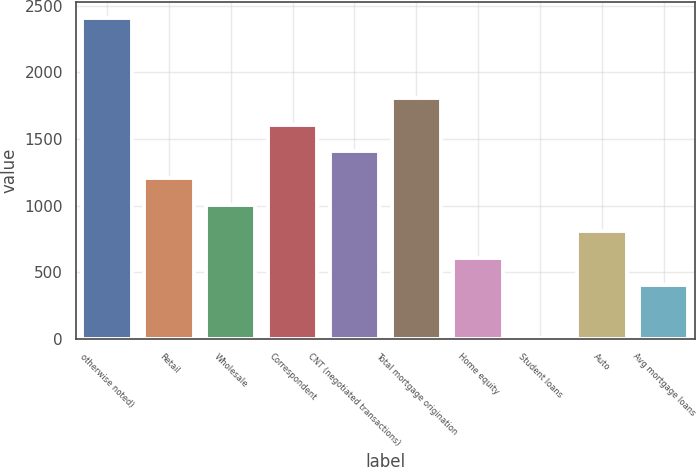Convert chart to OTSL. <chart><loc_0><loc_0><loc_500><loc_500><bar_chart><fcel>otherwise noted)<fcel>Retail<fcel>Wholesale<fcel>Correspondent<fcel>CNT (negotiated transactions)<fcel>Total mortgage origination<fcel>Home equity<fcel>Student loans<fcel>Auto<fcel>Avg mortgage loans<nl><fcel>2408.22<fcel>1207.56<fcel>1007.45<fcel>1607.78<fcel>1407.67<fcel>1807.89<fcel>607.23<fcel>6.9<fcel>807.34<fcel>407.12<nl></chart> 